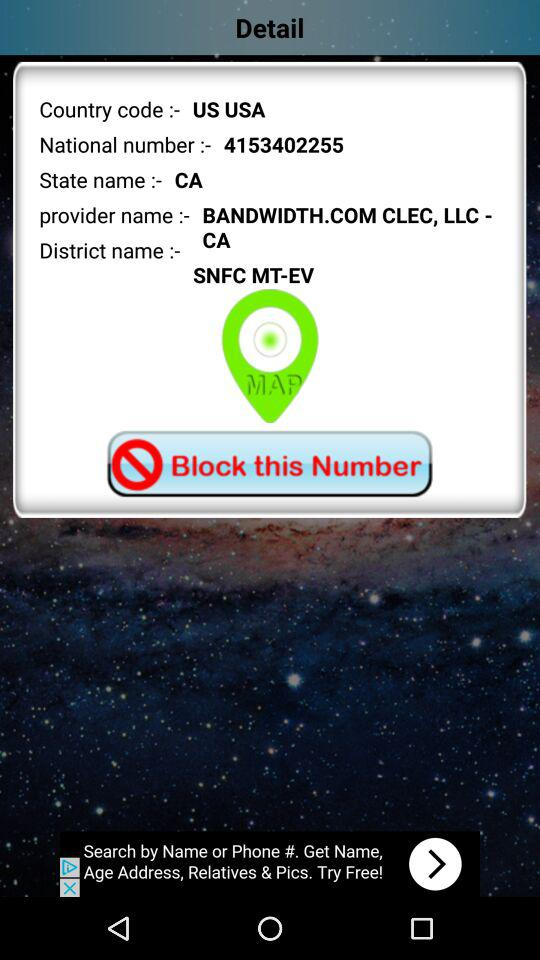What is the district name? The district name is SNFC MT-EV. 